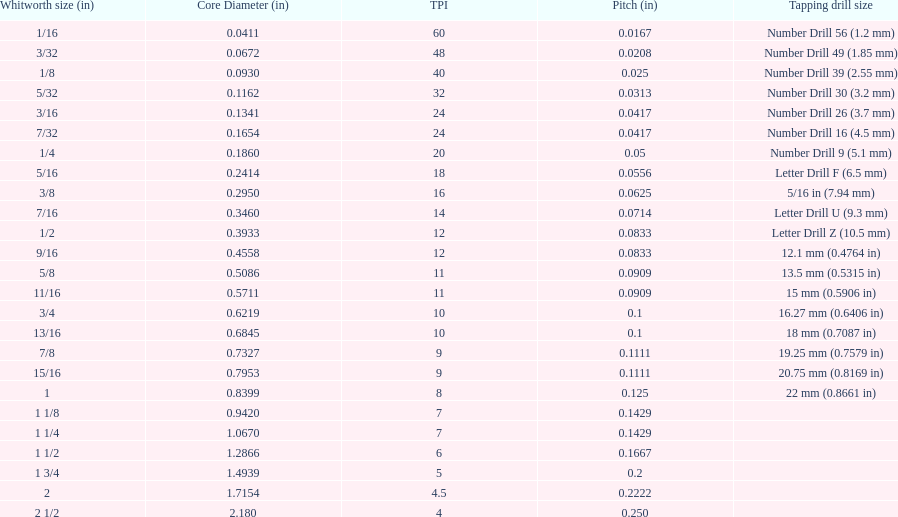What is the core diameter of the last whitworth thread size? 2.180. 